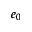<formula> <loc_0><loc_0><loc_500><loc_500>e _ { 0 }</formula> 